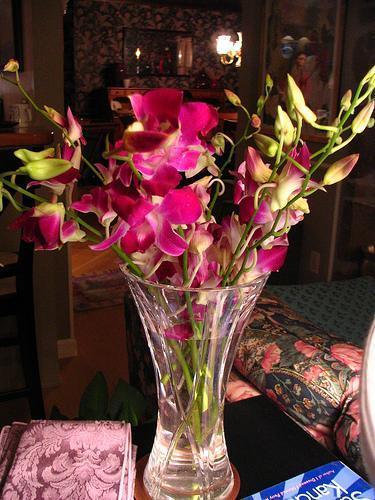How many vases?
Give a very brief answer. 1. How many vases have orange flowers in them?
Give a very brief answer. 0. 